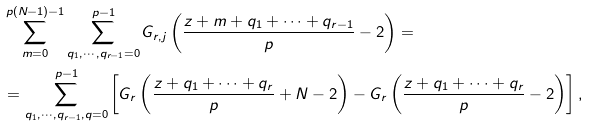<formula> <loc_0><loc_0><loc_500><loc_500>& \sum _ { m = 0 } ^ { p ( N - 1 ) - 1 } \sum _ { q _ { 1 } , \cdots , q _ { r - 1 } = 0 } ^ { p - 1 } G _ { r , j } \left ( \frac { z + m + q _ { 1 } + \cdots + q _ { r - 1 } } p - 2 \right ) = \\ & = \sum _ { q _ { 1 } , \cdots , q _ { r - 1 } , q = 0 } ^ { p - 1 } \left [ G _ { r } \left ( \frac { z + q _ { 1 } + \cdots + q _ { r } } p + N - 2 \right ) - G _ { r } \left ( \frac { z + q _ { 1 } + \cdots + q _ { r } } p - 2 \right ) \right ] ,</formula> 